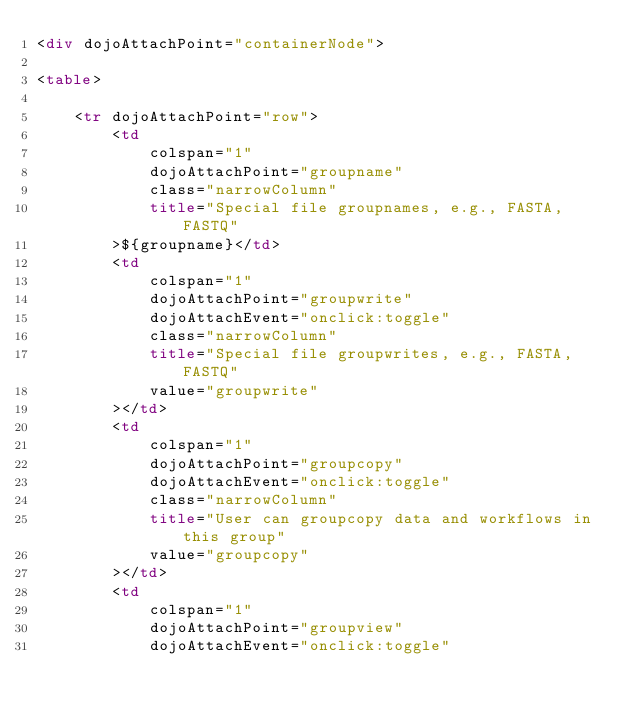Convert code to text. <code><loc_0><loc_0><loc_500><loc_500><_HTML_><div dojoAttachPoint="containerNode">

<table>
    
    <tr dojoAttachPoint="row">
        <td 
            colspan="1"
            dojoAttachPoint="groupname"
            class="narrowColumn"
            title="Special file groupnames, e.g., FASTA, FASTQ"
        >${groupname}</td>
        <td 
            colspan="1"
            dojoAttachPoint="groupwrite"
            dojoAttachEvent="onclick:toggle"
            class="narrowColumn"
            title="Special file groupwrites, e.g., FASTA, FASTQ"
            value="groupwrite"
        ></td>
        <td
            colspan="1"
            dojoAttachPoint="groupcopy"
            dojoAttachEvent="onclick:toggle"
            class="narrowColumn"
            title="User can groupcopy data and workflows in this group"
            value="groupcopy"
        ></td>
        <td
            colspan="1"
            dojoAttachPoint="groupview"
            dojoAttachEvent="onclick:toggle"</code> 